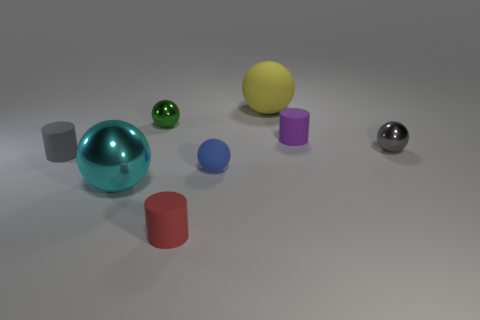Subtract 1 spheres. How many spheres are left? 4 Subtract all cyan spheres. How many spheres are left? 4 Subtract all big cyan balls. How many balls are left? 4 Subtract all purple spheres. Subtract all green cylinders. How many spheres are left? 5 Add 2 small brown shiny blocks. How many objects exist? 10 Subtract all cylinders. How many objects are left? 5 Add 2 yellow spheres. How many yellow spheres are left? 3 Add 7 small blue balls. How many small blue balls exist? 8 Subtract 0 red spheres. How many objects are left? 8 Subtract all small blue blocks. Subtract all purple objects. How many objects are left? 7 